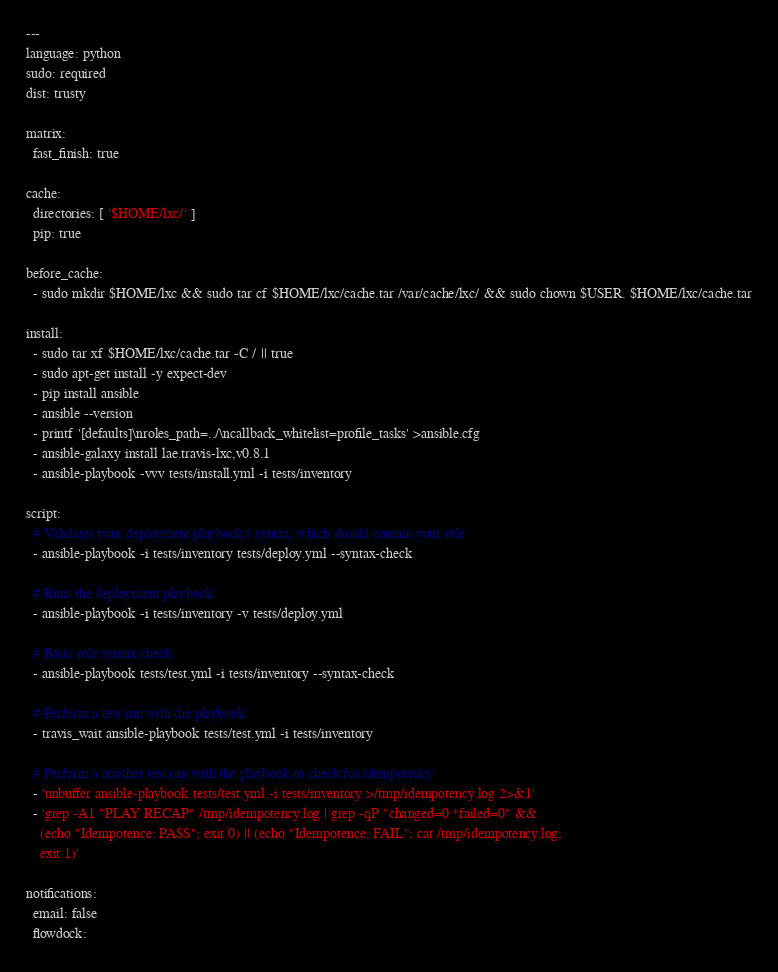Convert code to text. <code><loc_0><loc_0><loc_500><loc_500><_YAML_>---
language: python
sudo: required
dist: trusty

matrix:
  fast_finish: true

cache:
  directories: [ '$HOME/lxc/' ]
  pip: true

before_cache:
  - sudo mkdir $HOME/lxc && sudo tar cf $HOME/lxc/cache.tar /var/cache/lxc/ && sudo chown $USER. $HOME/lxc/cache.tar

install:
  - sudo tar xf $HOME/lxc/cache.tar -C / || true
  - sudo apt-get install -y expect-dev
  - pip install ansible
  - ansible --version
  - printf '[defaults]\nroles_path=../\ncallback_whitelist=profile_tasks' >ansible.cfg
  - ansible-galaxy install lae.travis-lxc,v0.8.1
  - ansible-playbook -vvv tests/install.yml -i tests/inventory

script:
  # Validates your deployment playbook's syntax, which should contain your role
  - ansible-playbook -i tests/inventory tests/deploy.yml --syntax-check

  # Runs the deployment playbook
  - ansible-playbook -i tests/inventory -v tests/deploy.yml

  # Basic role syntax check
  - ansible-playbook tests/test.yml -i tests/inventory --syntax-check

  # Perform a test run with the playbook
  - travis_wait ansible-playbook tests/test.yml -i tests/inventory

  # Perform a another test run with the playbook to check for idempotency
  - 'unbuffer ansible-playbook tests/test.yml -i tests/inventory >/tmp/idempotency.log 2>&1'
  - 'grep -A1 "PLAY RECAP" /tmp/idempotency.log | grep -qP "changed=0.*failed=0" &&
    (echo "Idempotence: PASS"; exit 0) || (echo "Idempotence: FAIL"; cat /tmp/idempotency.log;
    exit 1)'

notifications:
  email: false
  flowdock:</code> 